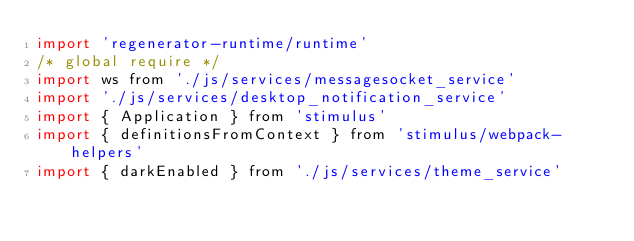<code> <loc_0><loc_0><loc_500><loc_500><_JavaScript_>import 'regenerator-runtime/runtime'
/* global require */
import ws from './js/services/messagesocket_service'
import './js/services/desktop_notification_service'
import { Application } from 'stimulus'
import { definitionsFromContext } from 'stimulus/webpack-helpers'
import { darkEnabled } from './js/services/theme_service'</code> 